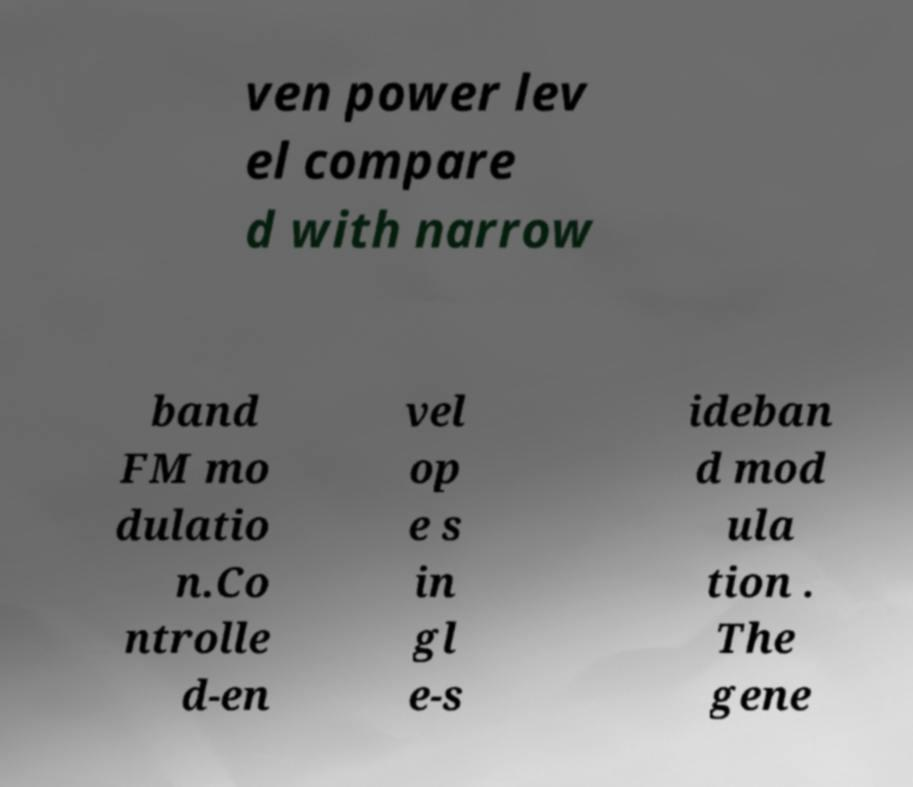Can you read and provide the text displayed in the image?This photo seems to have some interesting text. Can you extract and type it out for me? ven power lev el compare d with narrow band FM mo dulatio n.Co ntrolle d-en vel op e s in gl e-s ideban d mod ula tion . The gene 